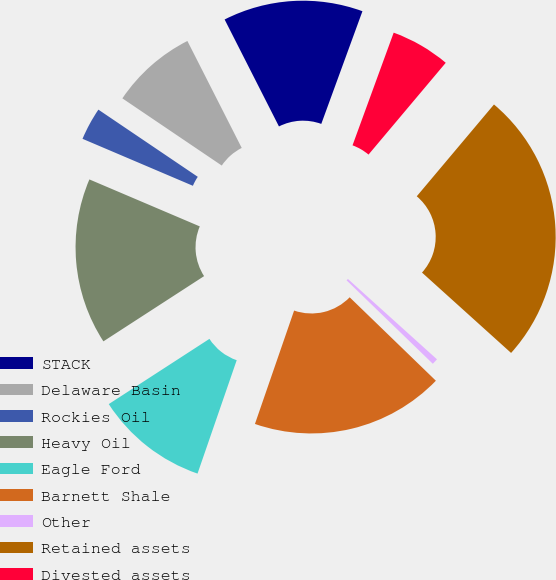<chart> <loc_0><loc_0><loc_500><loc_500><pie_chart><fcel>STACK<fcel>Delaware Basin<fcel>Rockies Oil<fcel>Heavy Oil<fcel>Eagle Ford<fcel>Barnett Shale<fcel>Other<fcel>Retained assets<fcel>Divested assets<nl><fcel>13.06%<fcel>8.06%<fcel>3.06%<fcel>15.56%<fcel>10.56%<fcel>18.06%<fcel>0.56%<fcel>25.56%<fcel>5.56%<nl></chart> 